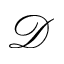Convert formula to latex. <formula><loc_0><loc_0><loc_500><loc_500>\mathcal { D }</formula> 